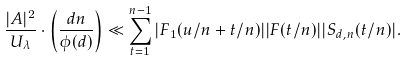<formula> <loc_0><loc_0><loc_500><loc_500>\frac { | A | ^ { 2 } } { U _ { \lambda } } \cdot \left ( \frac { d n } { \phi ( d ) } \right ) \ll \sum _ { t = 1 } ^ { n - 1 } | F _ { 1 } ( u / n + t / n ) | | F ( t / n ) | | S _ { d , n } ( t / n ) | .</formula> 